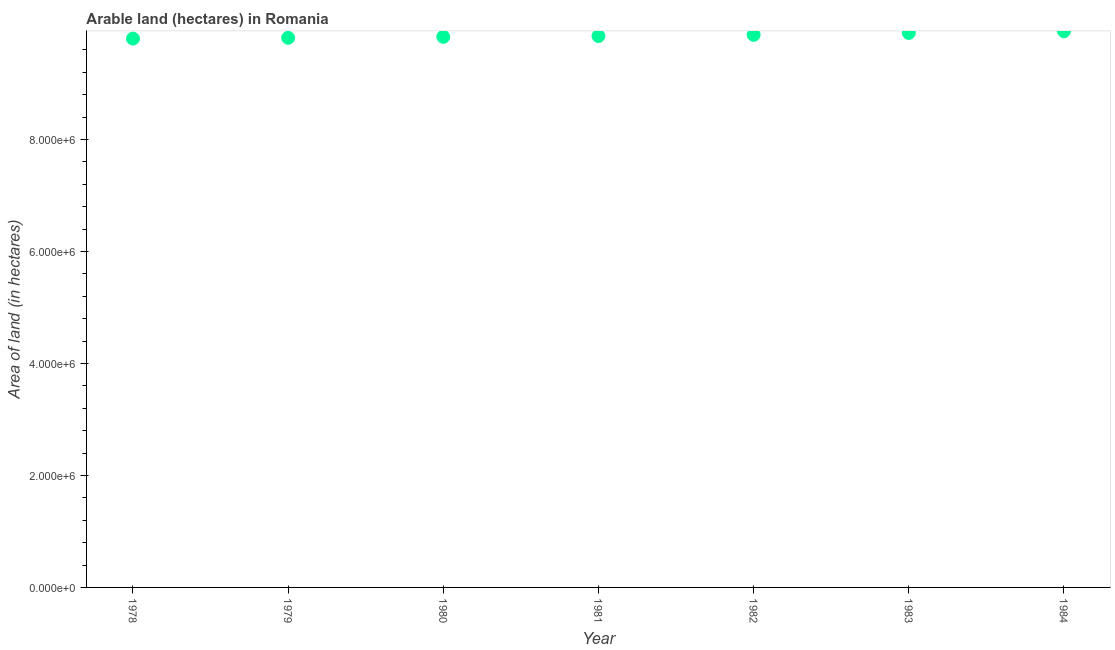What is the area of land in 1979?
Give a very brief answer. 9.82e+06. Across all years, what is the maximum area of land?
Your answer should be compact. 9.94e+06. Across all years, what is the minimum area of land?
Provide a short and direct response. 9.80e+06. In which year was the area of land maximum?
Your answer should be very brief. 1984. In which year was the area of land minimum?
Provide a succinct answer. 1978. What is the sum of the area of land?
Your response must be concise. 6.90e+07. What is the difference between the area of land in 1978 and 1984?
Keep it short and to the point. -1.32e+05. What is the average area of land per year?
Provide a short and direct response. 9.86e+06. What is the median area of land?
Your response must be concise. 9.85e+06. Do a majority of the years between 1978 and 1980 (inclusive) have area of land greater than 6000000 hectares?
Give a very brief answer. Yes. What is the ratio of the area of land in 1979 to that in 1984?
Your answer should be compact. 0.99. Is the area of land in 1978 less than that in 1981?
Your answer should be very brief. Yes. Is the difference between the area of land in 1979 and 1981 greater than the difference between any two years?
Your answer should be compact. No. What is the difference between the highest and the second highest area of land?
Your response must be concise. 3.10e+04. What is the difference between the highest and the lowest area of land?
Your answer should be very brief. 1.32e+05. In how many years, is the area of land greater than the average area of land taken over all years?
Your answer should be very brief. 3. How many dotlines are there?
Make the answer very short. 1. How many years are there in the graph?
Your answer should be compact. 7. Does the graph contain any zero values?
Give a very brief answer. No. What is the title of the graph?
Your answer should be compact. Arable land (hectares) in Romania. What is the label or title of the X-axis?
Ensure brevity in your answer.  Year. What is the label or title of the Y-axis?
Give a very brief answer. Area of land (in hectares). What is the Area of land (in hectares) in 1978?
Your answer should be compact. 9.80e+06. What is the Area of land (in hectares) in 1979?
Offer a very short reply. 9.82e+06. What is the Area of land (in hectares) in 1980?
Offer a terse response. 9.83e+06. What is the Area of land (in hectares) in 1981?
Your answer should be very brief. 9.85e+06. What is the Area of land (in hectares) in 1982?
Your response must be concise. 9.87e+06. What is the Area of land (in hectares) in 1983?
Make the answer very short. 9.90e+06. What is the Area of land (in hectares) in 1984?
Provide a succinct answer. 9.94e+06. What is the difference between the Area of land (in hectares) in 1978 and 1979?
Provide a succinct answer. -1.40e+04. What is the difference between the Area of land (in hectares) in 1978 and 1980?
Provide a short and direct response. -3.10e+04. What is the difference between the Area of land (in hectares) in 1978 and 1981?
Your answer should be very brief. -4.60e+04. What is the difference between the Area of land (in hectares) in 1978 and 1982?
Provide a short and direct response. -6.70e+04. What is the difference between the Area of land (in hectares) in 1978 and 1983?
Provide a short and direct response. -1.01e+05. What is the difference between the Area of land (in hectares) in 1978 and 1984?
Provide a short and direct response. -1.32e+05. What is the difference between the Area of land (in hectares) in 1979 and 1980?
Provide a short and direct response. -1.70e+04. What is the difference between the Area of land (in hectares) in 1979 and 1981?
Provide a short and direct response. -3.20e+04. What is the difference between the Area of land (in hectares) in 1979 and 1982?
Make the answer very short. -5.30e+04. What is the difference between the Area of land (in hectares) in 1979 and 1983?
Give a very brief answer. -8.70e+04. What is the difference between the Area of land (in hectares) in 1979 and 1984?
Provide a succinct answer. -1.18e+05. What is the difference between the Area of land (in hectares) in 1980 and 1981?
Make the answer very short. -1.50e+04. What is the difference between the Area of land (in hectares) in 1980 and 1982?
Your answer should be compact. -3.60e+04. What is the difference between the Area of land (in hectares) in 1980 and 1984?
Keep it short and to the point. -1.01e+05. What is the difference between the Area of land (in hectares) in 1981 and 1982?
Offer a terse response. -2.10e+04. What is the difference between the Area of land (in hectares) in 1981 and 1983?
Your answer should be very brief. -5.50e+04. What is the difference between the Area of land (in hectares) in 1981 and 1984?
Make the answer very short. -8.60e+04. What is the difference between the Area of land (in hectares) in 1982 and 1983?
Ensure brevity in your answer.  -3.40e+04. What is the difference between the Area of land (in hectares) in 1982 and 1984?
Ensure brevity in your answer.  -6.50e+04. What is the difference between the Area of land (in hectares) in 1983 and 1984?
Ensure brevity in your answer.  -3.10e+04. What is the ratio of the Area of land (in hectares) in 1978 to that in 1982?
Your answer should be very brief. 0.99. What is the ratio of the Area of land (in hectares) in 1978 to that in 1983?
Your answer should be very brief. 0.99. What is the ratio of the Area of land (in hectares) in 1978 to that in 1984?
Provide a succinct answer. 0.99. What is the ratio of the Area of land (in hectares) in 1979 to that in 1980?
Make the answer very short. 1. What is the ratio of the Area of land (in hectares) in 1979 to that in 1982?
Keep it short and to the point. 0.99. What is the ratio of the Area of land (in hectares) in 1979 to that in 1983?
Make the answer very short. 0.99. What is the ratio of the Area of land (in hectares) in 1979 to that in 1984?
Give a very brief answer. 0.99. What is the ratio of the Area of land (in hectares) in 1980 to that in 1981?
Keep it short and to the point. 1. What is the ratio of the Area of land (in hectares) in 1980 to that in 1982?
Offer a terse response. 1. What is the ratio of the Area of land (in hectares) in 1980 to that in 1983?
Your answer should be compact. 0.99. What is the ratio of the Area of land (in hectares) in 1981 to that in 1982?
Provide a short and direct response. 1. What is the ratio of the Area of land (in hectares) in 1981 to that in 1984?
Make the answer very short. 0.99. What is the ratio of the Area of land (in hectares) in 1982 to that in 1984?
Your response must be concise. 0.99. What is the ratio of the Area of land (in hectares) in 1983 to that in 1984?
Make the answer very short. 1. 